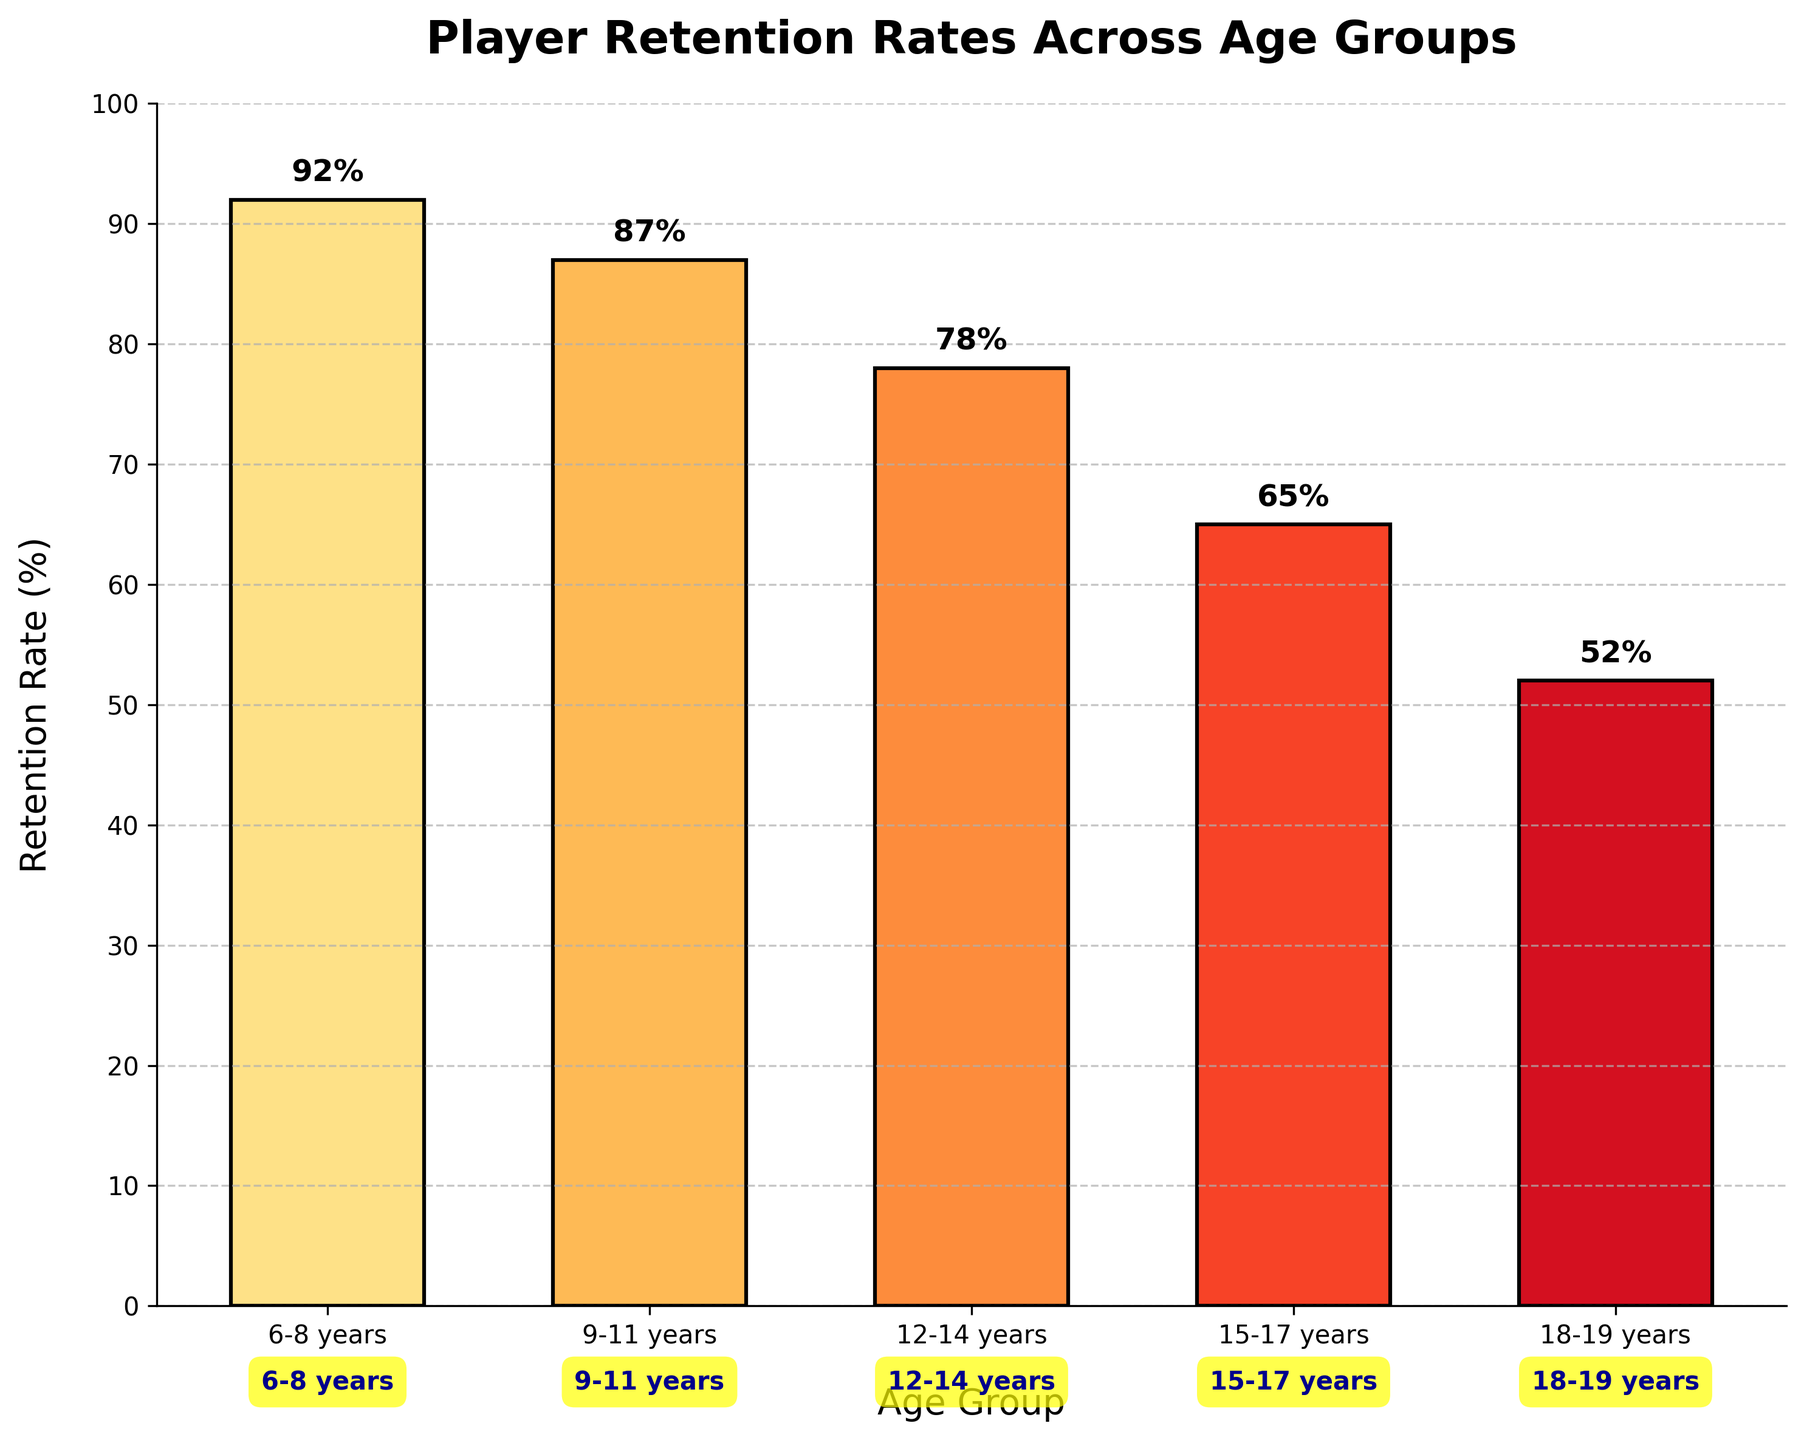What is the title of the chart? The title is displayed at the top of the chart. It is "Player Retention Rates Across Age Groups."
Answer: Player Retention Rates Across Age Groups What are the age groups displayed on the x-axis? The labels on the x-axis show the different age groups: "6-8 years," "9-11 years," "12-14 years," "15-17 years," and "18-19 years."
Answer: 6-8 years, 9-11 years, 12-14 years, 15-17 years, 18-19 years What retention rate is shown for the 12-14 years age group? By looking at the bar corresponding to the 12-14 years age group, the retention rate displayed is 78%.
Answer: 78% Which age group has the lowest retention rate? Comparing all the bars, the shortest one corresponds to the 18-19 years age group, indicating it has the lowest retention rate.
Answer: 18-19 years By how much does the retention rate decrease from 6-8 years to 12-14 years? The retention rate for 6-8 years is 92%, and for 12-14 years, it is 78%. Subtracting these gives 92% - 78% = 14%.
Answer: 14% What is the average retention rate across all age groups? The retention rates are 92%, 87%, 78%, 65%, and 52%. Summing these gives 374%. Dividing by 5 age groups gives 374% / 5 = 74.8%.
Answer: 74.8% Which age group has a higher retention rate: 9-11 years or 15-17 years? Comparing the bars for 9-11 years and 15-17 years, the bar for 9-11 years is higher, indicating a higher retention rate.
Answer: 9-11 years What is the difference in retention rates between the highest and lowest age groups? The highest retention rate is 92% (6-8 years) and the lowest is 52% (18-19 years). The difference is 92% - 52% = 40%.
Answer: 40% Order the age groups from the highest to lowest retention rate. Observing the heights of the bars, we list them from the tallest to the shortest: 6-8 years (92%), 9-11 years (87%), 12-14 years (78%), 15-17 years (65%), 18-19 years (52%).
Answer: 6-8 years, 9-11 years, 12-14 years, 15-17 years, 18-19 years 